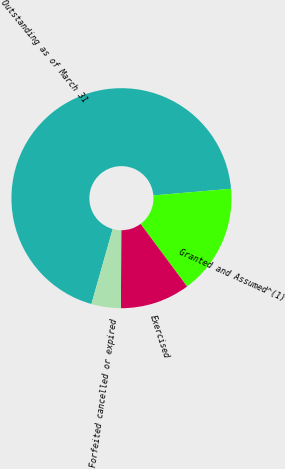Convert chart. <chart><loc_0><loc_0><loc_500><loc_500><pie_chart><fcel>Outstanding as of March 31<fcel>Granted and Assumed^(1)<fcel>Exercised<fcel>Forfeited cancelled or expired<nl><fcel>69.24%<fcel>16.19%<fcel>10.25%<fcel>4.32%<nl></chart> 